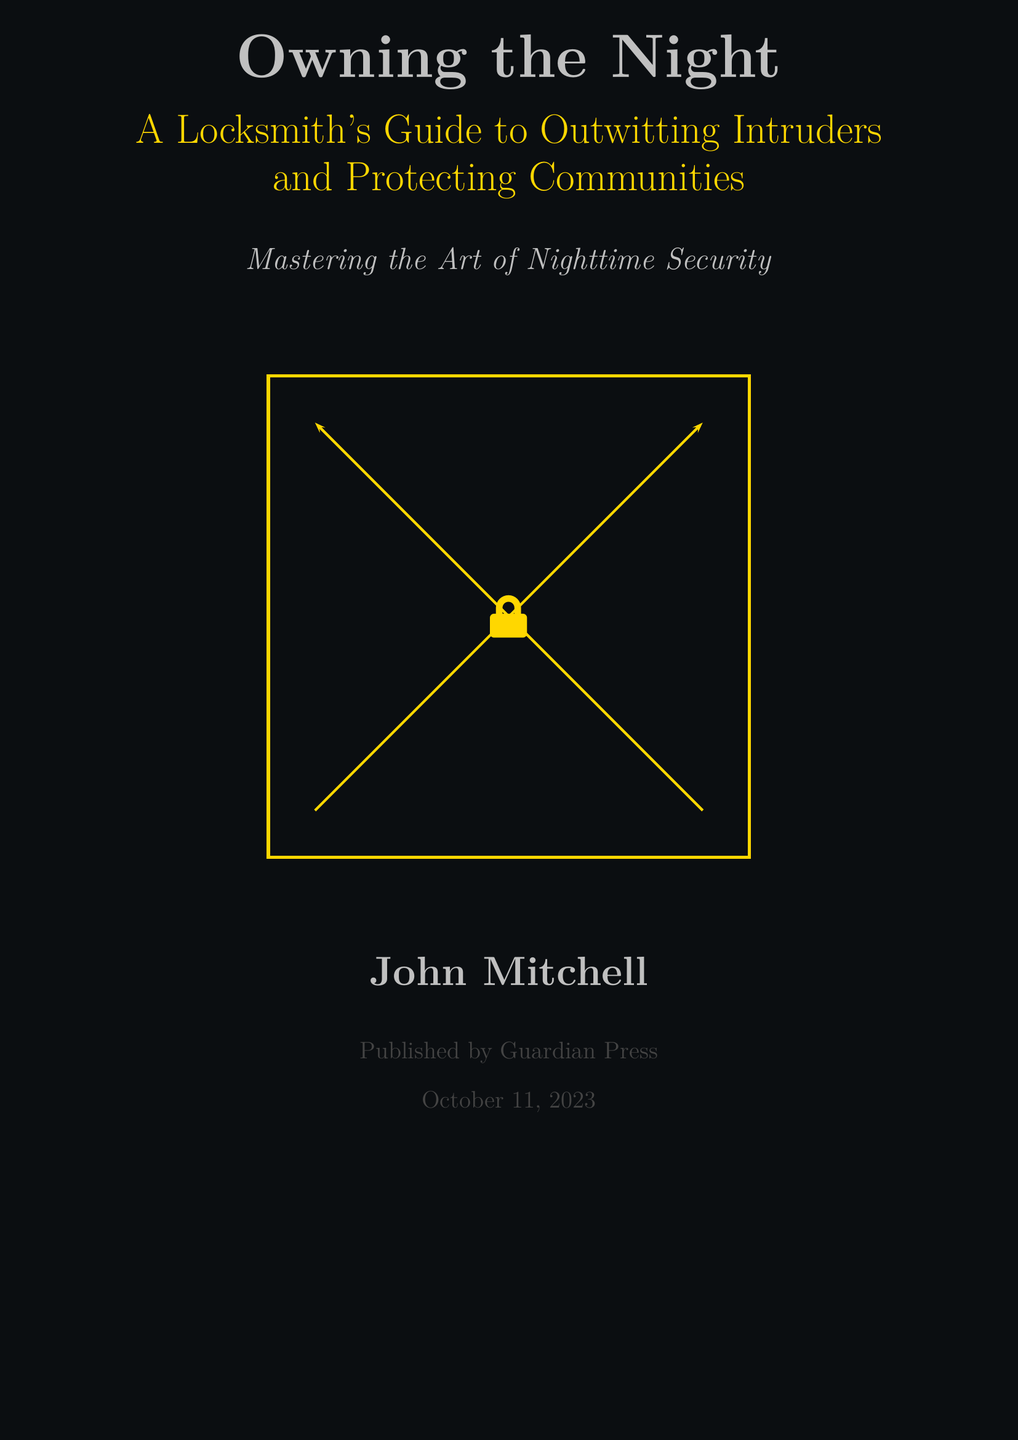What is the title of the book? The title is prominently featured at the top of the cover, stated as "Owning the Night."
Answer: Owning the Night Who is the author of the book? The author's name is listed towards the bottom of the cover, indicated as "John Mitchell."
Answer: John Mitchell What is the publication date? The publication date is mentioned in the lower section, which states "October 11, 2023."
Answer: October 11, 2023 What kind of guide is it? The subtitle of the book describes it as "A Locksmith's Guide to Outwitting Intruders."
Answer: A Locksmith's Guide to Outwitting Intruders What color represents the night sky on the cover? The cover utilizes a dark color defined in the document as "nightsky."
Answer: nightsky What is the main theme highlighted in the book? The phrase "Mastering the Art of Nighttime Security" suggests that the book focuses on security-related strategies.
Answer: Mastering the Art of Nighttime Security What publishing company is associated with the book? The publishing company is identified in the cover design as "Guardian Press."
Answer: Guardian Press What color is used for the security elements in the cover? The color that is associated with security elements is referred to as "securitygold."
Answer: securitygold 